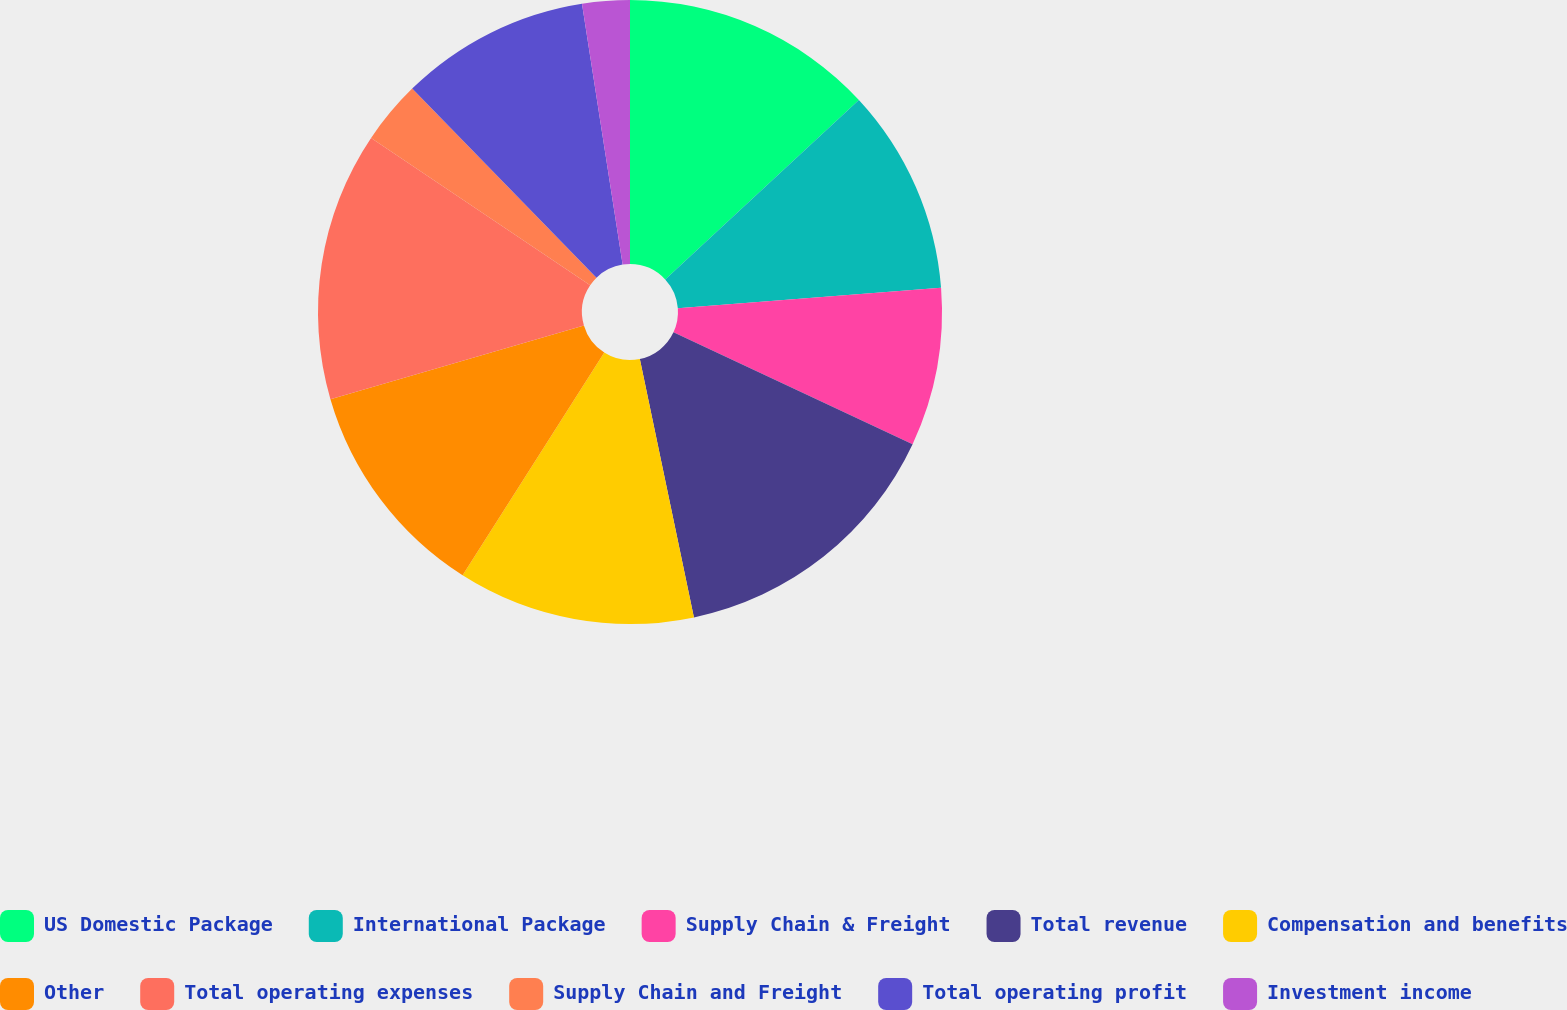<chart> <loc_0><loc_0><loc_500><loc_500><pie_chart><fcel>US Domestic Package<fcel>International Package<fcel>Supply Chain & Freight<fcel>Total revenue<fcel>Compensation and benefits<fcel>Other<fcel>Total operating expenses<fcel>Supply Chain and Freight<fcel>Total operating profit<fcel>Investment income<nl><fcel>13.11%<fcel>10.66%<fcel>8.2%<fcel>14.75%<fcel>12.3%<fcel>11.48%<fcel>13.93%<fcel>3.28%<fcel>9.84%<fcel>2.46%<nl></chart> 